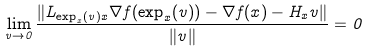<formula> <loc_0><loc_0><loc_500><loc_500>\lim _ { v \to 0 } \frac { \| L _ { \exp _ { x } ( v ) x } \nabla f ( \exp _ { x } ( v ) ) - \nabla f ( x ) - H _ { x } v \| } { \| v \| } = 0</formula> 